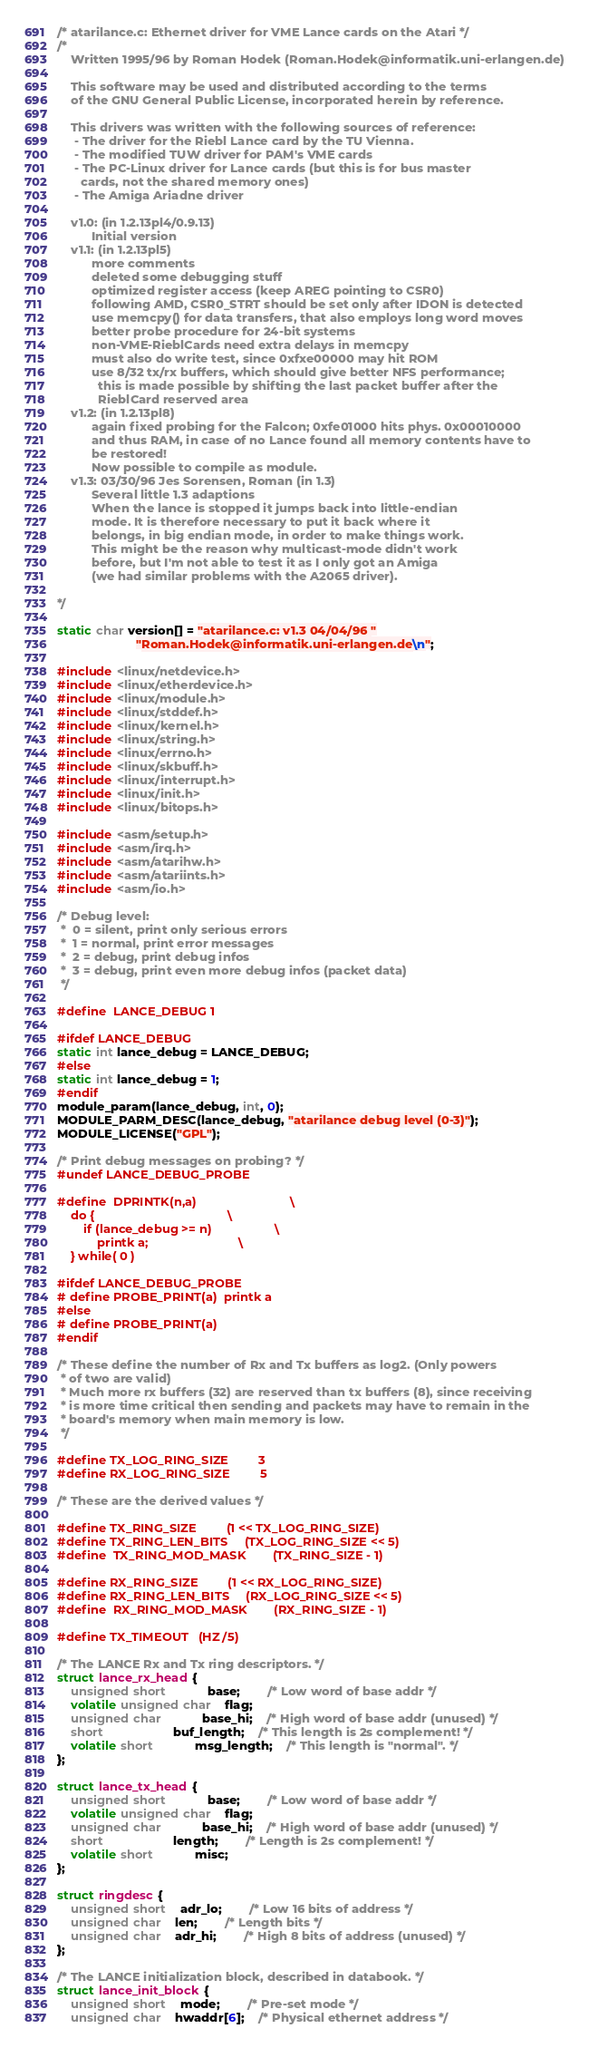<code> <loc_0><loc_0><loc_500><loc_500><_C_>/* atarilance.c: Ethernet driver for VME Lance cards on the Atari */
/*
	Written 1995/96 by Roman Hodek (Roman.Hodek@informatik.uni-erlangen.de)

	This software may be used and distributed according to the terms
	of the GNU General Public License, incorporated herein by reference.

	This drivers was written with the following sources of reference:
	 - The driver for the Riebl Lance card by the TU Vienna.
	 - The modified TUW driver for PAM's VME cards
	 - The PC-Linux driver for Lance cards (but this is for bus master
       cards, not the shared memory ones)
	 - The Amiga Ariadne driver

	v1.0: (in 1.2.13pl4/0.9.13)
	      Initial version
	v1.1: (in 1.2.13pl5)
	      more comments
		  deleted some debugging stuff
		  optimized register access (keep AREG pointing to CSR0)
		  following AMD, CSR0_STRT should be set only after IDON is detected
		  use memcpy() for data transfers, that also employs long word moves
		  better probe procedure for 24-bit systems
          non-VME-RieblCards need extra delays in memcpy
		  must also do write test, since 0xfxe00000 may hit ROM
		  use 8/32 tx/rx buffers, which should give better NFS performance;
		    this is made possible by shifting the last packet buffer after the
		    RieblCard reserved area
    v1.2: (in 1.2.13pl8)
	      again fixed probing for the Falcon; 0xfe01000 hits phys. 0x00010000
		  and thus RAM, in case of no Lance found all memory contents have to
		  be restored!
		  Now possible to compile as module.
	v1.3: 03/30/96 Jes Sorensen, Roman (in 1.3)
	      Several little 1.3 adaptions
		  When the lance is stopped it jumps back into little-endian
		  mode. It is therefore necessary to put it back where it
		  belongs, in big endian mode, in order to make things work.
		  This might be the reason why multicast-mode didn't work
		  before, but I'm not able to test it as I only got an Amiga
		  (we had similar problems with the A2065 driver).

*/

static char version[] = "atarilance.c: v1.3 04/04/96 "
					   "Roman.Hodek@informatik.uni-erlangen.de\n";

#include <linux/netdevice.h>
#include <linux/etherdevice.h>
#include <linux/module.h>
#include <linux/stddef.h>
#include <linux/kernel.h>
#include <linux/string.h>
#include <linux/errno.h>
#include <linux/skbuff.h>
#include <linux/interrupt.h>
#include <linux/init.h>
#include <linux/bitops.h>

#include <asm/setup.h>
#include <asm/irq.h>
#include <asm/atarihw.h>
#include <asm/atariints.h>
#include <asm/io.h>

/* Debug level:
 *  0 = silent, print only serious errors
 *  1 = normal, print error messages
 *  2 = debug, print debug infos
 *  3 = debug, print even more debug infos (packet data)
 */

#define	LANCE_DEBUG	1

#ifdef LANCE_DEBUG
static int lance_debug = LANCE_DEBUG;
#else
static int lance_debug = 1;
#endif
module_param(lance_debug, int, 0);
MODULE_PARM_DESC(lance_debug, "atarilance debug level (0-3)");
MODULE_LICENSE("GPL");

/* Print debug messages on probing? */
#undef LANCE_DEBUG_PROBE

#define	DPRINTK(n,a)							\
	do {										\
		if (lance_debug >= n)					\
			printk a;							\
	} while( 0 )

#ifdef LANCE_DEBUG_PROBE
# define PROBE_PRINT(a)	printk a
#else
# define PROBE_PRINT(a)
#endif

/* These define the number of Rx and Tx buffers as log2. (Only powers
 * of two are valid)
 * Much more rx buffers (32) are reserved than tx buffers (8), since receiving
 * is more time critical then sending and packets may have to remain in the
 * board's memory when main memory is low.
 */

#define TX_LOG_RING_SIZE			3
#define RX_LOG_RING_SIZE			5

/* These are the derived values */

#define TX_RING_SIZE			(1 << TX_LOG_RING_SIZE)
#define TX_RING_LEN_BITS		(TX_LOG_RING_SIZE << 5)
#define	TX_RING_MOD_MASK		(TX_RING_SIZE - 1)

#define RX_RING_SIZE			(1 << RX_LOG_RING_SIZE)
#define RX_RING_LEN_BITS		(RX_LOG_RING_SIZE << 5)
#define	RX_RING_MOD_MASK		(RX_RING_SIZE - 1)

#define TX_TIMEOUT	(HZ/5)

/* The LANCE Rx and Tx ring descriptors. */
struct lance_rx_head {
	unsigned short			base;		/* Low word of base addr */
	volatile unsigned char	flag;
	unsigned char			base_hi;	/* High word of base addr (unused) */
	short					buf_length;	/* This length is 2s complement! */
	volatile short			msg_length;	/* This length is "normal". */
};

struct lance_tx_head {
	unsigned short			base;		/* Low word of base addr */
	volatile unsigned char	flag;
	unsigned char			base_hi;	/* High word of base addr (unused) */
	short					length;		/* Length is 2s complement! */
	volatile short			misc;
};

struct ringdesc {
	unsigned short	adr_lo;		/* Low 16 bits of address */
	unsigned char	len;		/* Length bits */
	unsigned char	adr_hi;		/* High 8 bits of address (unused) */
};

/* The LANCE initialization block, described in databook. */
struct lance_init_block {
	unsigned short	mode;		/* Pre-set mode */
	unsigned char	hwaddr[6];	/* Physical ethernet address */</code> 